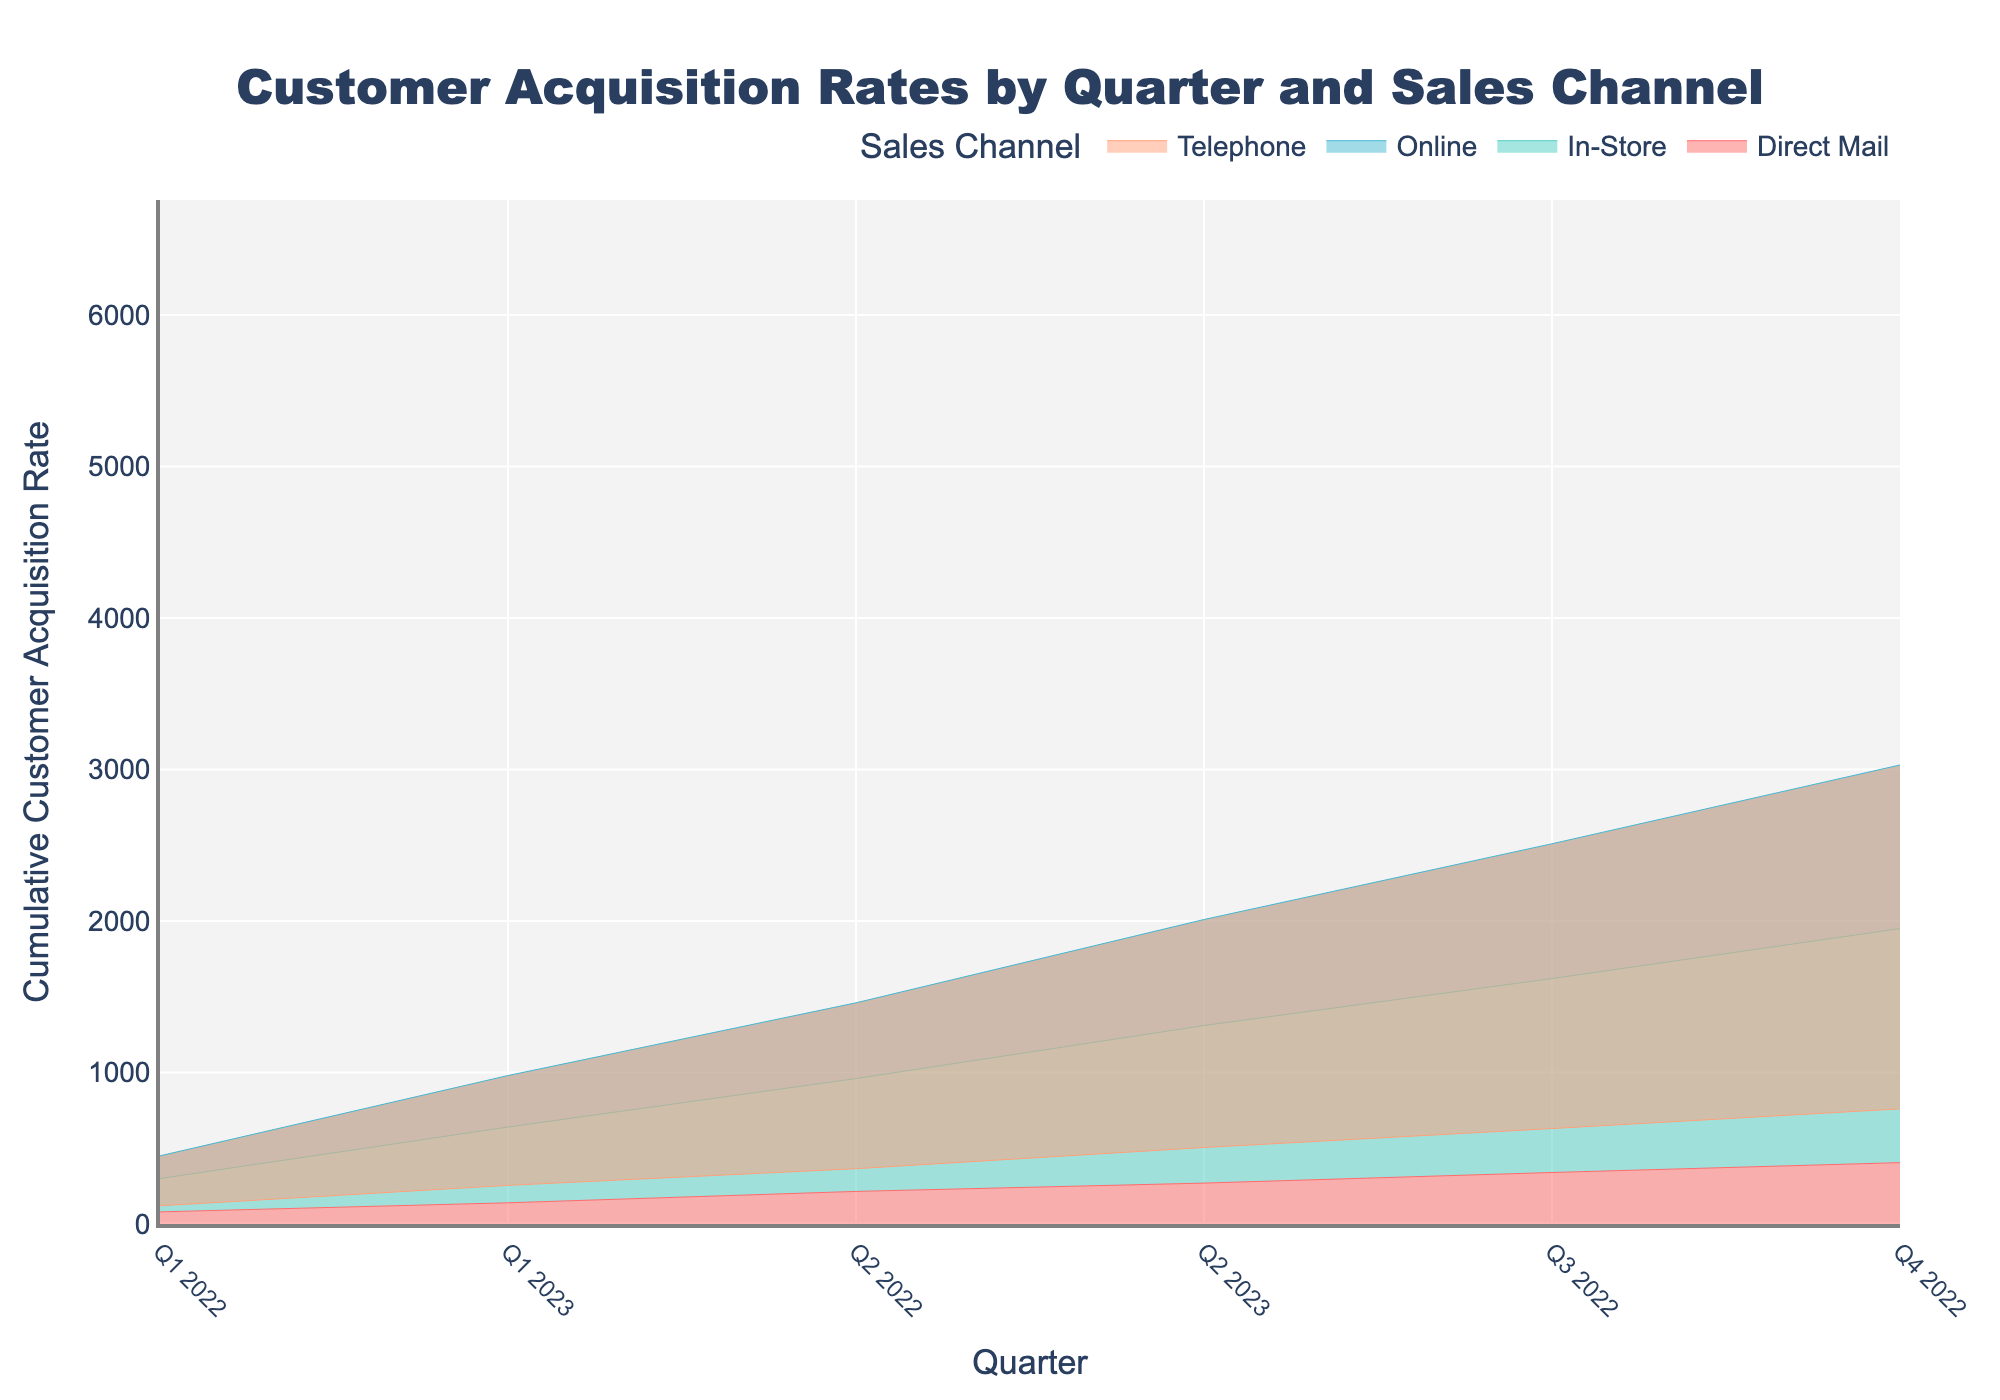What is the title of the chart? The chart title is usually found at the top and prominently displayed. Here it reads "Customer Acquisition Rates by Quarter and Sales Channel."
Answer: Customer Acquisition Rates by Quarter and Sales Channel What does the x-axis represent? The x-axis represents the quarters over the time period from Q1 2022 to Q2 2023. This is indicated by the labels on the axis.
Answer: Quarter How many sales channels are used in this analysis? By looking at the legend, there are four sales channels used: Online, In-Store, Telephone, and Direct Mail.
Answer: Four Which sales channel has the highest cumulative customer acquisition rate by Q2 2023? By observing the chart, the area corresponding to each sales channel's cumulative acquisition rate shows that the 'Online' sales channel has the highest cumulative rate by Q2 2023.
Answer: Online How did the customer acquisition rate for Direct Mail change from Q1 2022 to Q2 2023? To find this, look at the y-values for Direct Mail in Q1 2022 (80) and Q2 2023 (55). The rate decreased by (80-55) over the period.
Answer: Decreased What is the cumulative customer acquisition rate for the In-Store channel by Q4 2022? The cumulative rate can be found by summing the quarterly rates for the In-Store channel up to Q4 2022: 300 + 320 + 310 + 330 = 1260.
Answer: 1260 Which channel shows the smallest difference in acquisition rates between two consecutive quarters? By comparing the differences between quarterly rates across channels, it is observed that Direct Mail shows the smallest differences, e.g., Q1 to Q2 (80 to 75), Q2 to Q3 (75 to 70), etc.
Answer: Direct Mail Between which quarters did the Telephone channel experience a drop in customer acquisition rates? Analyze the changes in rates for the Telephone channel between consecutive quarters. The drop is observed between Q1 2022 (120) and Q2 2022 (110).
Answer: Q1 2022 to Q2 2022 What is the total customer acquisition rate from all channels combined by Q2 2023? Sum the cumulative values for all channels by Q2 2023. Online: 450+480+500+520+530+550 = 3030, In-Store: 300+320+310+330+340+350 = 1950, Telephone: 120+110+125+130+135+140 = 760, Direct Mail: 80+75+70+65+60+55 = 405. Total: 3030 + 1950 + 760 + 405 = 6145.
Answer: 6145 